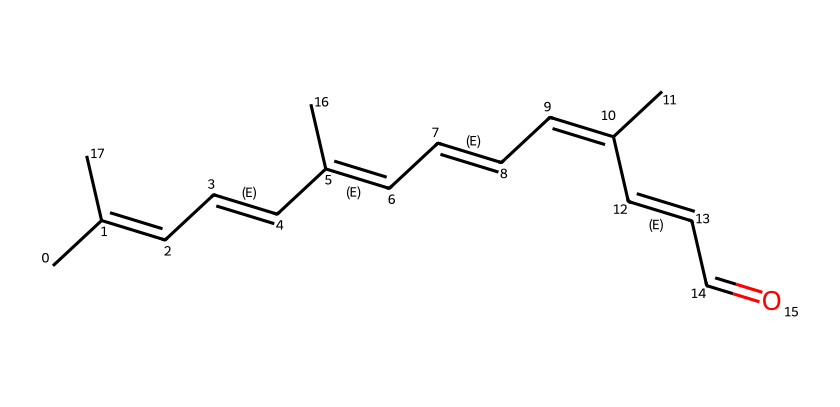What is the molecular formula of retinal? To find the molecular formula, we can count the number of carbon (C), hydrogen (H), and oxygen (O) atoms in the SMILES representation. The molecule consists of 20 carbon atoms, 28 hydrogen atoms, and 1 oxygen atom, which gives us the formula C20H28O.
Answer: C20H28O How many double bonds are present in retinal? By analyzing the structure, we can see that there are 5 double bonds (indicated by the "C=C" parts in the SMILES). Each "C=C" notation represents a double bond.
Answer: 5 What type of isomerism is exhibited by retinal? Retinal exhibits geometric (cis-trans) isomerism due to the presence of multiple double bonds that can have different spatial arrangements, resulting in different geometric configurations.
Answer: geometric isomerism What is the role of retinal in biological systems? Retinal is crucial for visual perception as it is a key component of the visual cycle, converting light into electrical signals in the retina. This role is integral to vision.
Answer: vision How many geometric isomers can retinal potentially have? Considering retinal has multiple double bonds with the possibility of cis/trans arrangements, specifically, with 5 double bonds, but not all will give rise to independent geometric isomers. For this molecule, the geometric isomers can be calculated to find there may be a handful, but due to non-unique arrangements, it typically contributes to a few distinct isomers, around 2 to 4 depending on preference.
Answer: 4 What does the presence of the aldehyde group indicate about retinal's properties? The aldehyde group (C=O) at the end of the retinal structure contributes to its reactivity and solubility in polar solvents, impacting its behavior in biological systems as a reactive compound.
Answer: reactivity 